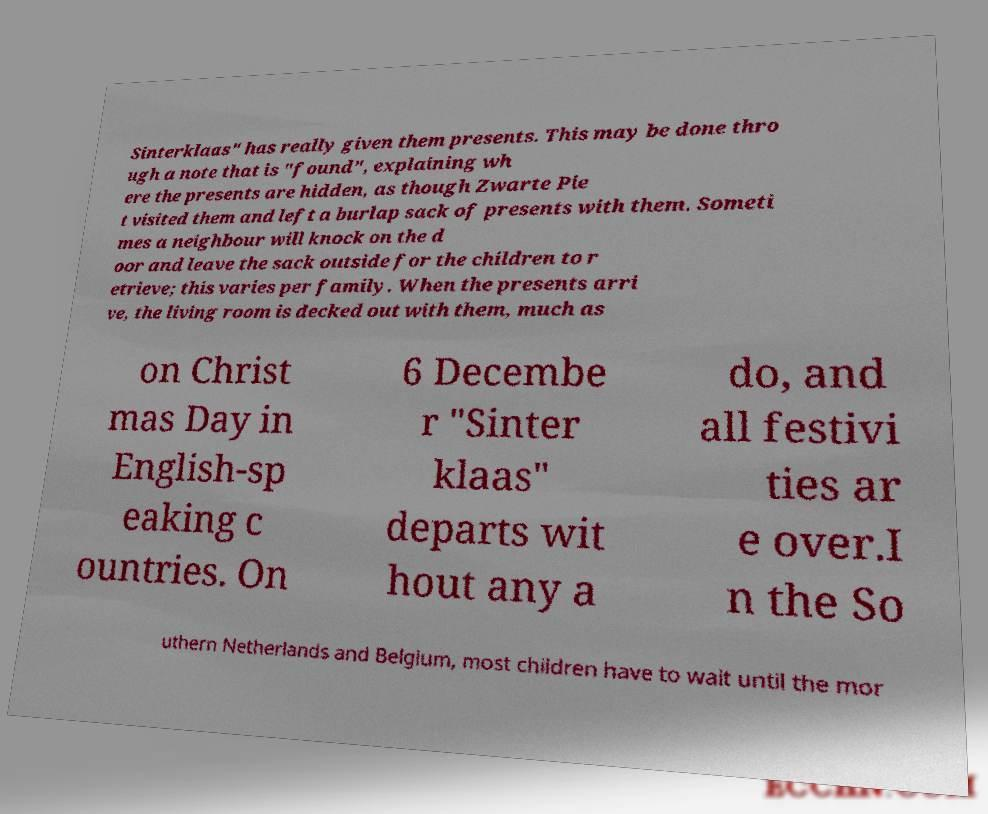Please identify and transcribe the text found in this image. Sinterklaas" has really given them presents. This may be done thro ugh a note that is "found", explaining wh ere the presents are hidden, as though Zwarte Pie t visited them and left a burlap sack of presents with them. Someti mes a neighbour will knock on the d oor and leave the sack outside for the children to r etrieve; this varies per family. When the presents arri ve, the living room is decked out with them, much as on Christ mas Day in English-sp eaking c ountries. On 6 Decembe r "Sinter klaas" departs wit hout any a do, and all festivi ties ar e over.I n the So uthern Netherlands and Belgium, most children have to wait until the mor 